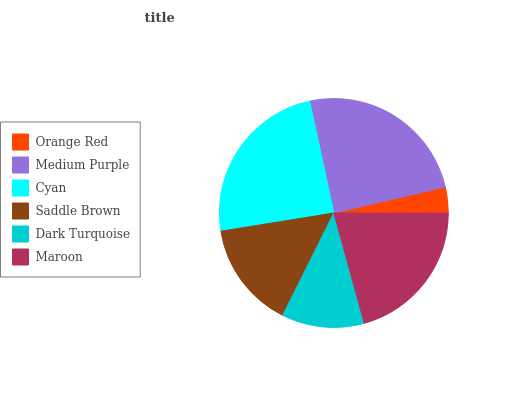Is Orange Red the minimum?
Answer yes or no. Yes. Is Medium Purple the maximum?
Answer yes or no. Yes. Is Cyan the minimum?
Answer yes or no. No. Is Cyan the maximum?
Answer yes or no. No. Is Medium Purple greater than Cyan?
Answer yes or no. Yes. Is Cyan less than Medium Purple?
Answer yes or no. Yes. Is Cyan greater than Medium Purple?
Answer yes or no. No. Is Medium Purple less than Cyan?
Answer yes or no. No. Is Maroon the high median?
Answer yes or no. Yes. Is Saddle Brown the low median?
Answer yes or no. Yes. Is Cyan the high median?
Answer yes or no. No. Is Dark Turquoise the low median?
Answer yes or no. No. 